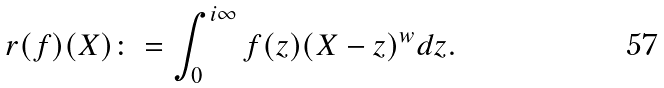<formula> <loc_0><loc_0><loc_500><loc_500>r ( f ) ( X ) \colon = \int _ { 0 } ^ { i \infty } f ( z ) ( X - z ) ^ { w } d z .</formula> 